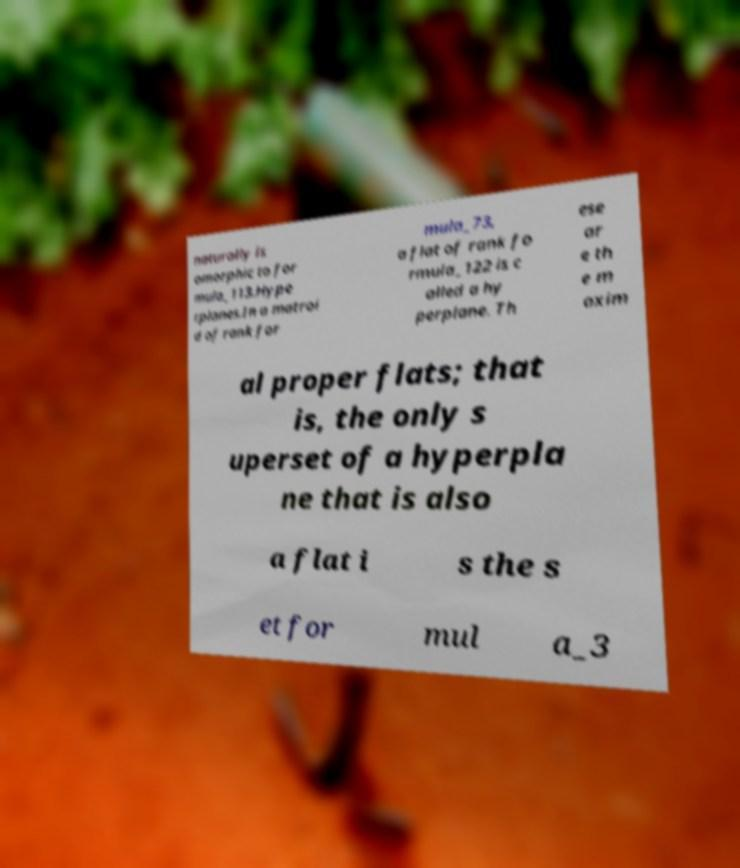Could you assist in decoding the text presented in this image and type it out clearly? naturally is omorphic to for mula_113.Hype rplanes.In a matroi d of rank for mula_73, a flat of rank fo rmula_122 is c alled a hy perplane. Th ese ar e th e m axim al proper flats; that is, the only s uperset of a hyperpla ne that is also a flat i s the s et for mul a_3 